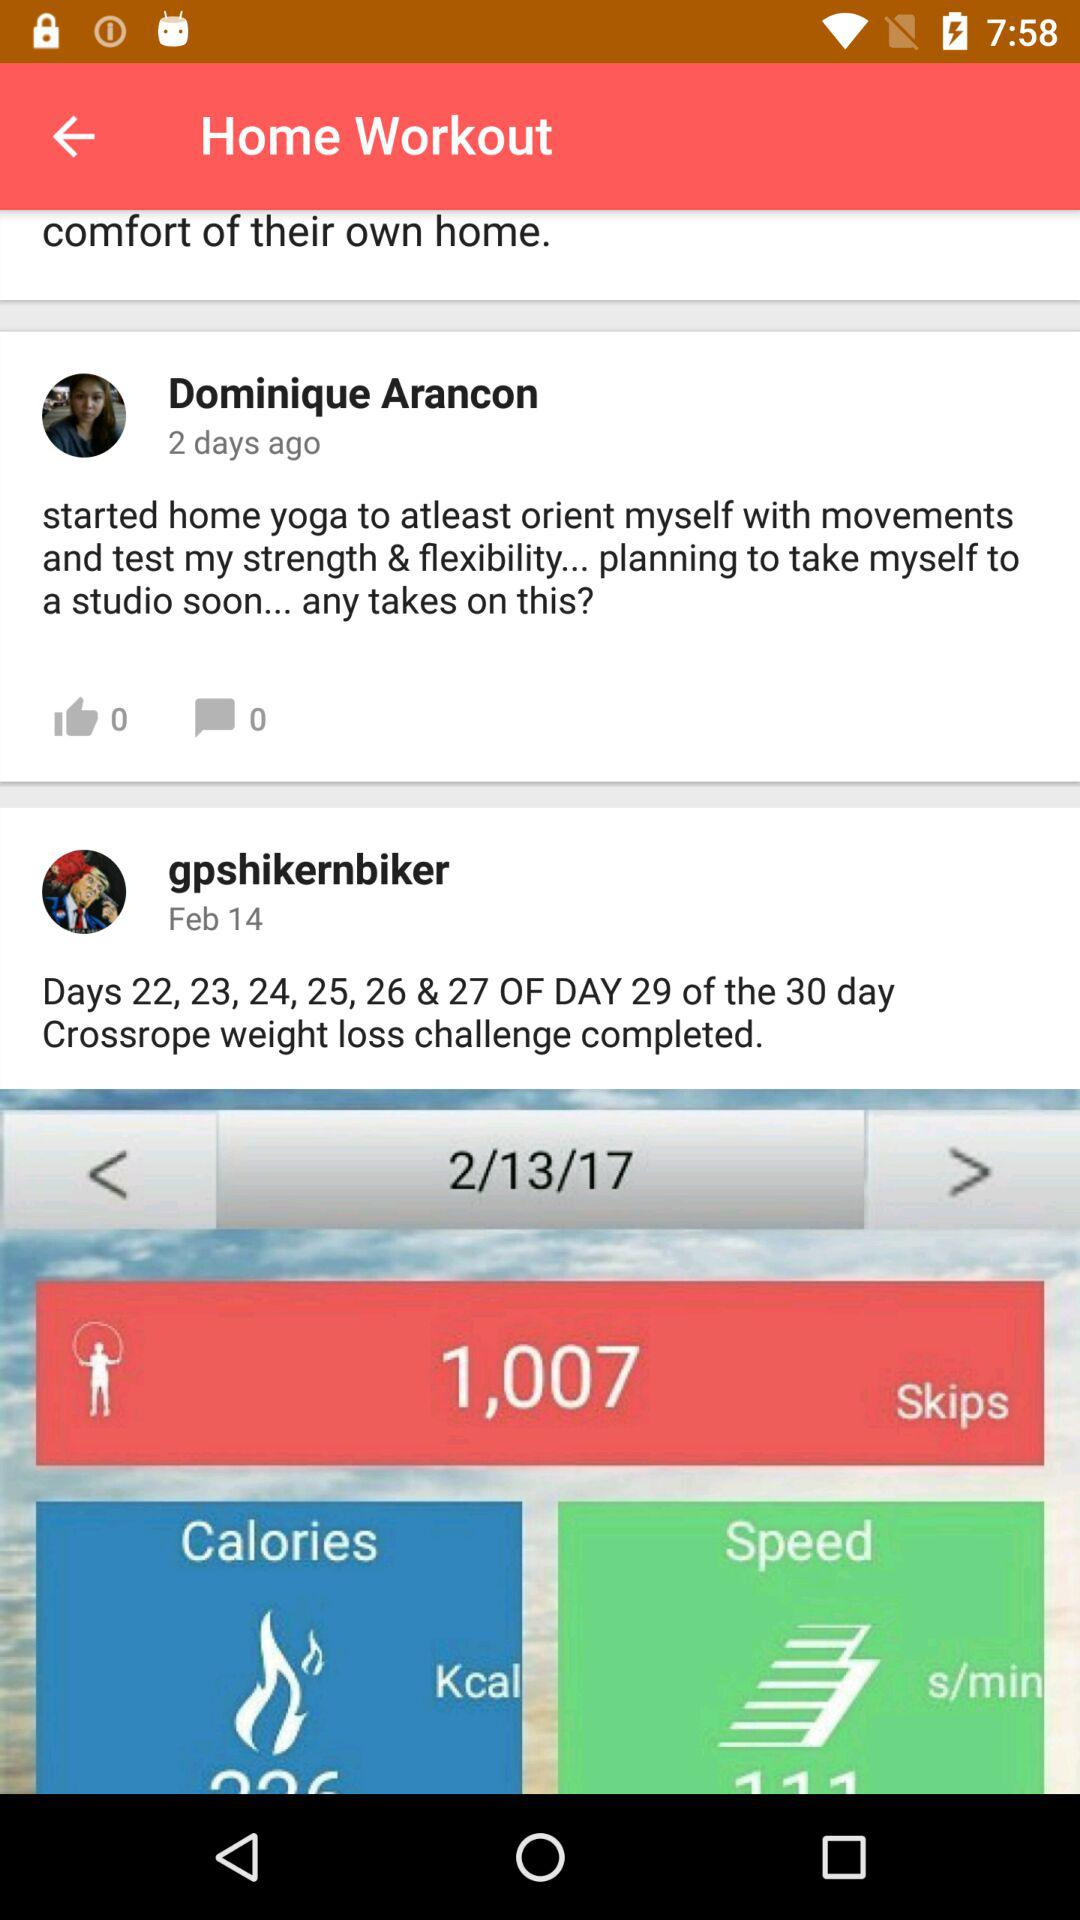What date is displayed? The displayed dates are February 14 and February 13, 2017. 